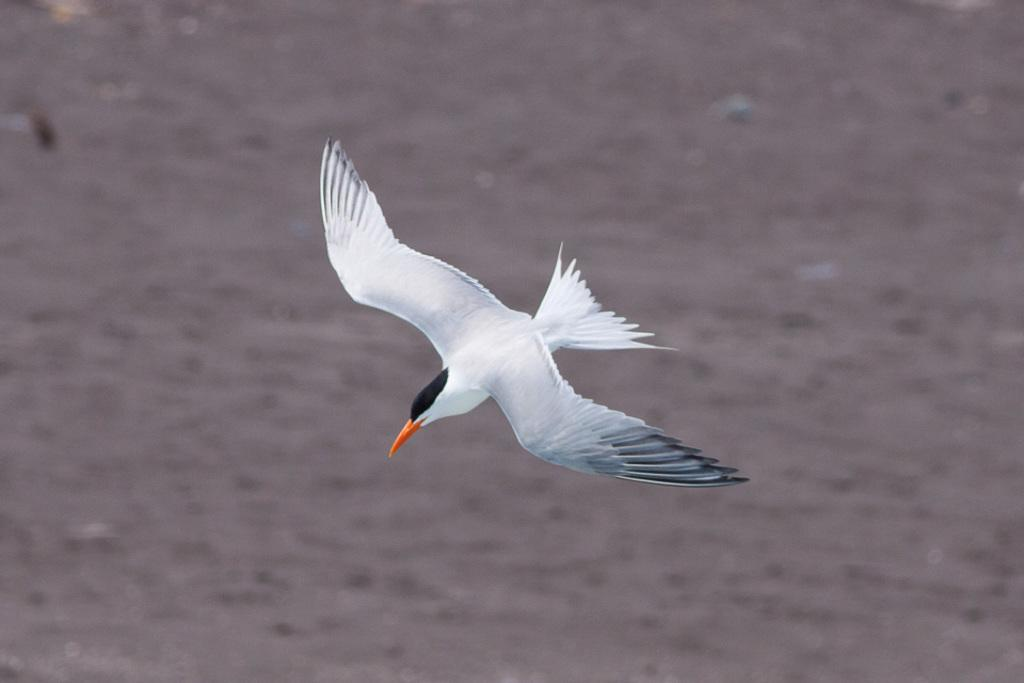What type of bird can be seen in the image? There is a white bird with an orange beak in the image. What is the bird doing in the image? The bird is flying. What can be seen at the bottom of the image? There is water visible at the bottom of the image. Where is the goat in the image? There is no goat present in the image. How many drops of water are visible in the image? The image does not show individual drops of water; it shows a body of water. 